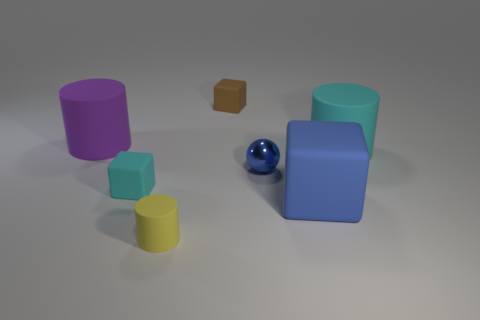What number of other things are the same color as the tiny cylinder?
Offer a very short reply. 0. Are there more big blue metal cylinders than cubes?
Make the answer very short. No. Are the small yellow cylinder and the brown block made of the same material?
Keep it short and to the point. Yes. Is there anything else that has the same material as the small blue thing?
Provide a short and direct response. No. Are there more small cyan rubber objects that are in front of the large purple rubber cylinder than tiny yellow cubes?
Make the answer very short. Yes. Do the ball and the big rubber block have the same color?
Offer a very short reply. Yes. What number of matte objects are the same shape as the blue shiny thing?
Make the answer very short. 0. What is the size of the purple cylinder that is made of the same material as the cyan cylinder?
Your answer should be very brief. Large. What is the color of the rubber thing that is to the left of the yellow cylinder and to the right of the purple matte cylinder?
Your answer should be compact. Cyan. What number of brown blocks are the same size as the yellow matte cylinder?
Provide a short and direct response. 1. 